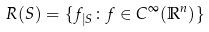Convert formula to latex. <formula><loc_0><loc_0><loc_500><loc_500>R ( S ) = \{ f _ { | S } \colon f \in C ^ { \infty } ( \mathbb { R } ^ { n } ) \}</formula> 